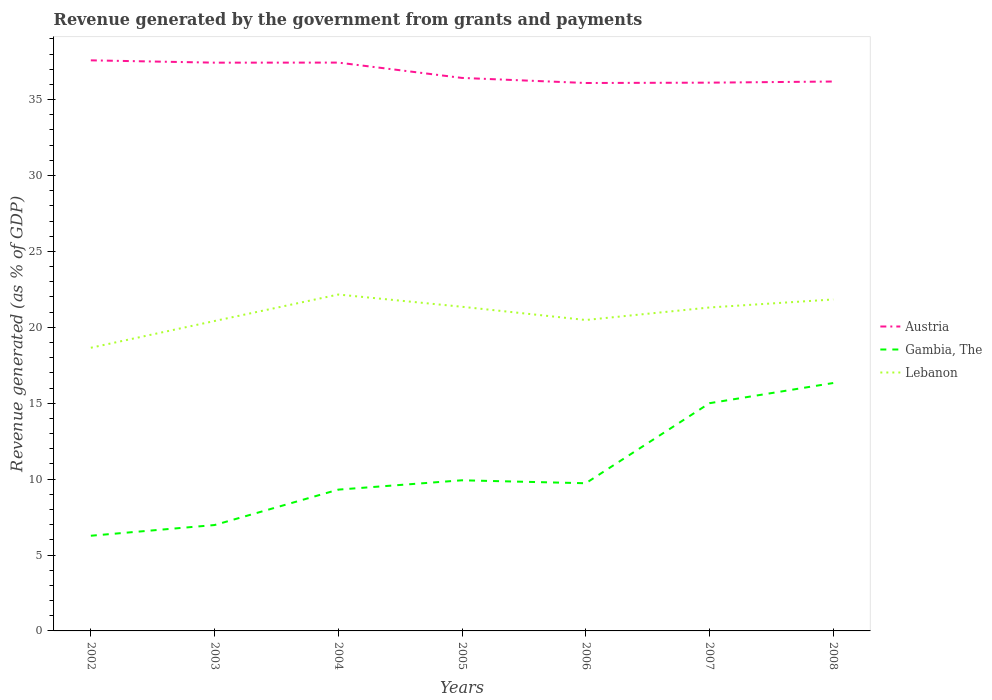How many different coloured lines are there?
Offer a very short reply. 3. Across all years, what is the maximum revenue generated by the government in Austria?
Your answer should be very brief. 36.09. In which year was the revenue generated by the government in Gambia, The maximum?
Keep it short and to the point. 2002. What is the total revenue generated by the government in Gambia, The in the graph?
Keep it short and to the point. -10.06. What is the difference between the highest and the second highest revenue generated by the government in Lebanon?
Offer a very short reply. 3.51. Is the revenue generated by the government in Lebanon strictly greater than the revenue generated by the government in Austria over the years?
Provide a short and direct response. Yes. How many lines are there?
Provide a succinct answer. 3. What is the difference between two consecutive major ticks on the Y-axis?
Give a very brief answer. 5. Does the graph contain any zero values?
Your answer should be very brief. No. Does the graph contain grids?
Give a very brief answer. No. How many legend labels are there?
Provide a succinct answer. 3. How are the legend labels stacked?
Keep it short and to the point. Vertical. What is the title of the graph?
Your response must be concise. Revenue generated by the government from grants and payments. Does "St. Lucia" appear as one of the legend labels in the graph?
Ensure brevity in your answer.  No. What is the label or title of the Y-axis?
Your answer should be very brief. Revenue generated (as % of GDP). What is the Revenue generated (as % of GDP) of Austria in 2002?
Your response must be concise. 37.58. What is the Revenue generated (as % of GDP) of Gambia, The in 2002?
Provide a succinct answer. 6.27. What is the Revenue generated (as % of GDP) in Lebanon in 2002?
Your answer should be compact. 18.65. What is the Revenue generated (as % of GDP) of Austria in 2003?
Your response must be concise. 37.43. What is the Revenue generated (as % of GDP) in Gambia, The in 2003?
Your answer should be very brief. 6.97. What is the Revenue generated (as % of GDP) in Lebanon in 2003?
Keep it short and to the point. 20.41. What is the Revenue generated (as % of GDP) of Austria in 2004?
Offer a very short reply. 37.44. What is the Revenue generated (as % of GDP) of Gambia, The in 2004?
Offer a terse response. 9.31. What is the Revenue generated (as % of GDP) of Lebanon in 2004?
Your answer should be very brief. 22.16. What is the Revenue generated (as % of GDP) in Austria in 2005?
Make the answer very short. 36.43. What is the Revenue generated (as % of GDP) in Gambia, The in 2005?
Make the answer very short. 9.92. What is the Revenue generated (as % of GDP) of Lebanon in 2005?
Offer a very short reply. 21.35. What is the Revenue generated (as % of GDP) of Austria in 2006?
Provide a succinct answer. 36.09. What is the Revenue generated (as % of GDP) of Gambia, The in 2006?
Provide a succinct answer. 9.73. What is the Revenue generated (as % of GDP) in Lebanon in 2006?
Offer a terse response. 20.48. What is the Revenue generated (as % of GDP) of Austria in 2007?
Your response must be concise. 36.11. What is the Revenue generated (as % of GDP) in Gambia, The in 2007?
Offer a very short reply. 15. What is the Revenue generated (as % of GDP) of Lebanon in 2007?
Make the answer very short. 21.31. What is the Revenue generated (as % of GDP) in Austria in 2008?
Make the answer very short. 36.19. What is the Revenue generated (as % of GDP) of Gambia, The in 2008?
Make the answer very short. 16.33. What is the Revenue generated (as % of GDP) in Lebanon in 2008?
Provide a short and direct response. 21.83. Across all years, what is the maximum Revenue generated (as % of GDP) in Austria?
Provide a short and direct response. 37.58. Across all years, what is the maximum Revenue generated (as % of GDP) of Gambia, The?
Keep it short and to the point. 16.33. Across all years, what is the maximum Revenue generated (as % of GDP) of Lebanon?
Your response must be concise. 22.16. Across all years, what is the minimum Revenue generated (as % of GDP) of Austria?
Your response must be concise. 36.09. Across all years, what is the minimum Revenue generated (as % of GDP) in Gambia, The?
Your answer should be compact. 6.27. Across all years, what is the minimum Revenue generated (as % of GDP) of Lebanon?
Make the answer very short. 18.65. What is the total Revenue generated (as % of GDP) of Austria in the graph?
Your answer should be very brief. 257.28. What is the total Revenue generated (as % of GDP) of Gambia, The in the graph?
Ensure brevity in your answer.  73.53. What is the total Revenue generated (as % of GDP) in Lebanon in the graph?
Give a very brief answer. 146.2. What is the difference between the Revenue generated (as % of GDP) of Austria in 2002 and that in 2003?
Ensure brevity in your answer.  0.15. What is the difference between the Revenue generated (as % of GDP) in Gambia, The in 2002 and that in 2003?
Give a very brief answer. -0.71. What is the difference between the Revenue generated (as % of GDP) in Lebanon in 2002 and that in 2003?
Keep it short and to the point. -1.76. What is the difference between the Revenue generated (as % of GDP) in Austria in 2002 and that in 2004?
Your answer should be compact. 0.15. What is the difference between the Revenue generated (as % of GDP) of Gambia, The in 2002 and that in 2004?
Ensure brevity in your answer.  -3.04. What is the difference between the Revenue generated (as % of GDP) in Lebanon in 2002 and that in 2004?
Your answer should be compact. -3.51. What is the difference between the Revenue generated (as % of GDP) of Austria in 2002 and that in 2005?
Your answer should be compact. 1.16. What is the difference between the Revenue generated (as % of GDP) in Gambia, The in 2002 and that in 2005?
Your answer should be compact. -3.65. What is the difference between the Revenue generated (as % of GDP) of Lebanon in 2002 and that in 2005?
Your answer should be compact. -2.7. What is the difference between the Revenue generated (as % of GDP) in Austria in 2002 and that in 2006?
Offer a terse response. 1.49. What is the difference between the Revenue generated (as % of GDP) of Gambia, The in 2002 and that in 2006?
Make the answer very short. -3.46. What is the difference between the Revenue generated (as % of GDP) in Lebanon in 2002 and that in 2006?
Provide a succinct answer. -1.83. What is the difference between the Revenue generated (as % of GDP) of Austria in 2002 and that in 2007?
Your response must be concise. 1.47. What is the difference between the Revenue generated (as % of GDP) of Gambia, The in 2002 and that in 2007?
Provide a succinct answer. -8.73. What is the difference between the Revenue generated (as % of GDP) in Lebanon in 2002 and that in 2007?
Your response must be concise. -2.65. What is the difference between the Revenue generated (as % of GDP) of Austria in 2002 and that in 2008?
Provide a short and direct response. 1.39. What is the difference between the Revenue generated (as % of GDP) of Gambia, The in 2002 and that in 2008?
Your answer should be very brief. -10.06. What is the difference between the Revenue generated (as % of GDP) of Lebanon in 2002 and that in 2008?
Provide a succinct answer. -3.18. What is the difference between the Revenue generated (as % of GDP) in Austria in 2003 and that in 2004?
Your answer should be very brief. -0. What is the difference between the Revenue generated (as % of GDP) in Gambia, The in 2003 and that in 2004?
Your answer should be compact. -2.33. What is the difference between the Revenue generated (as % of GDP) of Lebanon in 2003 and that in 2004?
Offer a very short reply. -1.74. What is the difference between the Revenue generated (as % of GDP) in Austria in 2003 and that in 2005?
Make the answer very short. 1.01. What is the difference between the Revenue generated (as % of GDP) of Gambia, The in 2003 and that in 2005?
Keep it short and to the point. -2.95. What is the difference between the Revenue generated (as % of GDP) of Lebanon in 2003 and that in 2005?
Your response must be concise. -0.94. What is the difference between the Revenue generated (as % of GDP) in Austria in 2003 and that in 2006?
Give a very brief answer. 1.34. What is the difference between the Revenue generated (as % of GDP) in Gambia, The in 2003 and that in 2006?
Offer a very short reply. -2.75. What is the difference between the Revenue generated (as % of GDP) of Lebanon in 2003 and that in 2006?
Provide a short and direct response. -0.07. What is the difference between the Revenue generated (as % of GDP) in Austria in 2003 and that in 2007?
Keep it short and to the point. 1.32. What is the difference between the Revenue generated (as % of GDP) in Gambia, The in 2003 and that in 2007?
Offer a terse response. -8.03. What is the difference between the Revenue generated (as % of GDP) of Lebanon in 2003 and that in 2007?
Make the answer very short. -0.89. What is the difference between the Revenue generated (as % of GDP) of Austria in 2003 and that in 2008?
Provide a short and direct response. 1.24. What is the difference between the Revenue generated (as % of GDP) of Gambia, The in 2003 and that in 2008?
Ensure brevity in your answer.  -9.36. What is the difference between the Revenue generated (as % of GDP) of Lebanon in 2003 and that in 2008?
Give a very brief answer. -1.42. What is the difference between the Revenue generated (as % of GDP) of Austria in 2004 and that in 2005?
Give a very brief answer. 1.01. What is the difference between the Revenue generated (as % of GDP) in Gambia, The in 2004 and that in 2005?
Offer a terse response. -0.62. What is the difference between the Revenue generated (as % of GDP) of Lebanon in 2004 and that in 2005?
Your answer should be very brief. 0.81. What is the difference between the Revenue generated (as % of GDP) in Austria in 2004 and that in 2006?
Your answer should be very brief. 1.34. What is the difference between the Revenue generated (as % of GDP) in Gambia, The in 2004 and that in 2006?
Provide a short and direct response. -0.42. What is the difference between the Revenue generated (as % of GDP) in Lebanon in 2004 and that in 2006?
Give a very brief answer. 1.68. What is the difference between the Revenue generated (as % of GDP) of Austria in 2004 and that in 2007?
Your response must be concise. 1.32. What is the difference between the Revenue generated (as % of GDP) in Gambia, The in 2004 and that in 2007?
Give a very brief answer. -5.69. What is the difference between the Revenue generated (as % of GDP) of Lebanon in 2004 and that in 2007?
Offer a terse response. 0.85. What is the difference between the Revenue generated (as % of GDP) of Austria in 2004 and that in 2008?
Your response must be concise. 1.25. What is the difference between the Revenue generated (as % of GDP) of Gambia, The in 2004 and that in 2008?
Your answer should be compact. -7.02. What is the difference between the Revenue generated (as % of GDP) of Lebanon in 2004 and that in 2008?
Provide a short and direct response. 0.33. What is the difference between the Revenue generated (as % of GDP) in Austria in 2005 and that in 2006?
Ensure brevity in your answer.  0.33. What is the difference between the Revenue generated (as % of GDP) in Gambia, The in 2005 and that in 2006?
Your response must be concise. 0.2. What is the difference between the Revenue generated (as % of GDP) of Lebanon in 2005 and that in 2006?
Provide a short and direct response. 0.87. What is the difference between the Revenue generated (as % of GDP) of Austria in 2005 and that in 2007?
Ensure brevity in your answer.  0.31. What is the difference between the Revenue generated (as % of GDP) in Gambia, The in 2005 and that in 2007?
Provide a succinct answer. -5.08. What is the difference between the Revenue generated (as % of GDP) of Lebanon in 2005 and that in 2007?
Ensure brevity in your answer.  0.05. What is the difference between the Revenue generated (as % of GDP) in Austria in 2005 and that in 2008?
Ensure brevity in your answer.  0.24. What is the difference between the Revenue generated (as % of GDP) in Gambia, The in 2005 and that in 2008?
Provide a succinct answer. -6.41. What is the difference between the Revenue generated (as % of GDP) in Lebanon in 2005 and that in 2008?
Provide a succinct answer. -0.48. What is the difference between the Revenue generated (as % of GDP) of Austria in 2006 and that in 2007?
Provide a short and direct response. -0.02. What is the difference between the Revenue generated (as % of GDP) in Gambia, The in 2006 and that in 2007?
Your response must be concise. -5.27. What is the difference between the Revenue generated (as % of GDP) in Lebanon in 2006 and that in 2007?
Provide a succinct answer. -0.82. What is the difference between the Revenue generated (as % of GDP) of Austria in 2006 and that in 2008?
Your answer should be very brief. -0.1. What is the difference between the Revenue generated (as % of GDP) of Gambia, The in 2006 and that in 2008?
Offer a very short reply. -6.6. What is the difference between the Revenue generated (as % of GDP) of Lebanon in 2006 and that in 2008?
Keep it short and to the point. -1.35. What is the difference between the Revenue generated (as % of GDP) in Austria in 2007 and that in 2008?
Provide a short and direct response. -0.07. What is the difference between the Revenue generated (as % of GDP) of Gambia, The in 2007 and that in 2008?
Your answer should be compact. -1.33. What is the difference between the Revenue generated (as % of GDP) in Lebanon in 2007 and that in 2008?
Ensure brevity in your answer.  -0.53. What is the difference between the Revenue generated (as % of GDP) of Austria in 2002 and the Revenue generated (as % of GDP) of Gambia, The in 2003?
Make the answer very short. 30.61. What is the difference between the Revenue generated (as % of GDP) in Austria in 2002 and the Revenue generated (as % of GDP) in Lebanon in 2003?
Your response must be concise. 17.17. What is the difference between the Revenue generated (as % of GDP) of Gambia, The in 2002 and the Revenue generated (as % of GDP) of Lebanon in 2003?
Make the answer very short. -14.15. What is the difference between the Revenue generated (as % of GDP) in Austria in 2002 and the Revenue generated (as % of GDP) in Gambia, The in 2004?
Offer a terse response. 28.28. What is the difference between the Revenue generated (as % of GDP) of Austria in 2002 and the Revenue generated (as % of GDP) of Lebanon in 2004?
Provide a succinct answer. 15.43. What is the difference between the Revenue generated (as % of GDP) of Gambia, The in 2002 and the Revenue generated (as % of GDP) of Lebanon in 2004?
Offer a terse response. -15.89. What is the difference between the Revenue generated (as % of GDP) in Austria in 2002 and the Revenue generated (as % of GDP) in Gambia, The in 2005?
Your response must be concise. 27.66. What is the difference between the Revenue generated (as % of GDP) of Austria in 2002 and the Revenue generated (as % of GDP) of Lebanon in 2005?
Provide a succinct answer. 16.23. What is the difference between the Revenue generated (as % of GDP) in Gambia, The in 2002 and the Revenue generated (as % of GDP) in Lebanon in 2005?
Offer a terse response. -15.08. What is the difference between the Revenue generated (as % of GDP) of Austria in 2002 and the Revenue generated (as % of GDP) of Gambia, The in 2006?
Provide a short and direct response. 27.86. What is the difference between the Revenue generated (as % of GDP) of Austria in 2002 and the Revenue generated (as % of GDP) of Lebanon in 2006?
Offer a very short reply. 17.1. What is the difference between the Revenue generated (as % of GDP) of Gambia, The in 2002 and the Revenue generated (as % of GDP) of Lebanon in 2006?
Your response must be concise. -14.21. What is the difference between the Revenue generated (as % of GDP) in Austria in 2002 and the Revenue generated (as % of GDP) in Gambia, The in 2007?
Your answer should be very brief. 22.58. What is the difference between the Revenue generated (as % of GDP) in Austria in 2002 and the Revenue generated (as % of GDP) in Lebanon in 2007?
Your answer should be very brief. 16.28. What is the difference between the Revenue generated (as % of GDP) of Gambia, The in 2002 and the Revenue generated (as % of GDP) of Lebanon in 2007?
Your response must be concise. -15.04. What is the difference between the Revenue generated (as % of GDP) in Austria in 2002 and the Revenue generated (as % of GDP) in Gambia, The in 2008?
Make the answer very short. 21.25. What is the difference between the Revenue generated (as % of GDP) in Austria in 2002 and the Revenue generated (as % of GDP) in Lebanon in 2008?
Offer a terse response. 15.75. What is the difference between the Revenue generated (as % of GDP) of Gambia, The in 2002 and the Revenue generated (as % of GDP) of Lebanon in 2008?
Make the answer very short. -15.56. What is the difference between the Revenue generated (as % of GDP) in Austria in 2003 and the Revenue generated (as % of GDP) in Gambia, The in 2004?
Your response must be concise. 28.12. What is the difference between the Revenue generated (as % of GDP) of Austria in 2003 and the Revenue generated (as % of GDP) of Lebanon in 2004?
Provide a succinct answer. 15.27. What is the difference between the Revenue generated (as % of GDP) in Gambia, The in 2003 and the Revenue generated (as % of GDP) in Lebanon in 2004?
Provide a succinct answer. -15.18. What is the difference between the Revenue generated (as % of GDP) of Austria in 2003 and the Revenue generated (as % of GDP) of Gambia, The in 2005?
Provide a succinct answer. 27.51. What is the difference between the Revenue generated (as % of GDP) in Austria in 2003 and the Revenue generated (as % of GDP) in Lebanon in 2005?
Your answer should be compact. 16.08. What is the difference between the Revenue generated (as % of GDP) of Gambia, The in 2003 and the Revenue generated (as % of GDP) of Lebanon in 2005?
Provide a succinct answer. -14.38. What is the difference between the Revenue generated (as % of GDP) in Austria in 2003 and the Revenue generated (as % of GDP) in Gambia, The in 2006?
Keep it short and to the point. 27.7. What is the difference between the Revenue generated (as % of GDP) of Austria in 2003 and the Revenue generated (as % of GDP) of Lebanon in 2006?
Make the answer very short. 16.95. What is the difference between the Revenue generated (as % of GDP) in Gambia, The in 2003 and the Revenue generated (as % of GDP) in Lebanon in 2006?
Keep it short and to the point. -13.51. What is the difference between the Revenue generated (as % of GDP) in Austria in 2003 and the Revenue generated (as % of GDP) in Gambia, The in 2007?
Ensure brevity in your answer.  22.43. What is the difference between the Revenue generated (as % of GDP) of Austria in 2003 and the Revenue generated (as % of GDP) of Lebanon in 2007?
Offer a terse response. 16.13. What is the difference between the Revenue generated (as % of GDP) of Gambia, The in 2003 and the Revenue generated (as % of GDP) of Lebanon in 2007?
Keep it short and to the point. -14.33. What is the difference between the Revenue generated (as % of GDP) in Austria in 2003 and the Revenue generated (as % of GDP) in Gambia, The in 2008?
Your response must be concise. 21.1. What is the difference between the Revenue generated (as % of GDP) of Austria in 2003 and the Revenue generated (as % of GDP) of Lebanon in 2008?
Make the answer very short. 15.6. What is the difference between the Revenue generated (as % of GDP) in Gambia, The in 2003 and the Revenue generated (as % of GDP) in Lebanon in 2008?
Keep it short and to the point. -14.86. What is the difference between the Revenue generated (as % of GDP) of Austria in 2004 and the Revenue generated (as % of GDP) of Gambia, The in 2005?
Your answer should be compact. 27.51. What is the difference between the Revenue generated (as % of GDP) in Austria in 2004 and the Revenue generated (as % of GDP) in Lebanon in 2005?
Provide a short and direct response. 16.08. What is the difference between the Revenue generated (as % of GDP) in Gambia, The in 2004 and the Revenue generated (as % of GDP) in Lebanon in 2005?
Offer a very short reply. -12.05. What is the difference between the Revenue generated (as % of GDP) of Austria in 2004 and the Revenue generated (as % of GDP) of Gambia, The in 2006?
Your answer should be compact. 27.71. What is the difference between the Revenue generated (as % of GDP) in Austria in 2004 and the Revenue generated (as % of GDP) in Lebanon in 2006?
Your answer should be compact. 16.96. What is the difference between the Revenue generated (as % of GDP) in Gambia, The in 2004 and the Revenue generated (as % of GDP) in Lebanon in 2006?
Make the answer very short. -11.17. What is the difference between the Revenue generated (as % of GDP) of Austria in 2004 and the Revenue generated (as % of GDP) of Gambia, The in 2007?
Offer a very short reply. 22.44. What is the difference between the Revenue generated (as % of GDP) of Austria in 2004 and the Revenue generated (as % of GDP) of Lebanon in 2007?
Give a very brief answer. 16.13. What is the difference between the Revenue generated (as % of GDP) in Gambia, The in 2004 and the Revenue generated (as % of GDP) in Lebanon in 2007?
Keep it short and to the point. -12. What is the difference between the Revenue generated (as % of GDP) of Austria in 2004 and the Revenue generated (as % of GDP) of Gambia, The in 2008?
Offer a terse response. 21.11. What is the difference between the Revenue generated (as % of GDP) in Austria in 2004 and the Revenue generated (as % of GDP) in Lebanon in 2008?
Your answer should be very brief. 15.6. What is the difference between the Revenue generated (as % of GDP) of Gambia, The in 2004 and the Revenue generated (as % of GDP) of Lebanon in 2008?
Provide a short and direct response. -12.53. What is the difference between the Revenue generated (as % of GDP) in Austria in 2005 and the Revenue generated (as % of GDP) in Gambia, The in 2006?
Offer a very short reply. 26.7. What is the difference between the Revenue generated (as % of GDP) of Austria in 2005 and the Revenue generated (as % of GDP) of Lebanon in 2006?
Provide a succinct answer. 15.95. What is the difference between the Revenue generated (as % of GDP) of Gambia, The in 2005 and the Revenue generated (as % of GDP) of Lebanon in 2006?
Your answer should be very brief. -10.56. What is the difference between the Revenue generated (as % of GDP) of Austria in 2005 and the Revenue generated (as % of GDP) of Gambia, The in 2007?
Ensure brevity in your answer.  21.43. What is the difference between the Revenue generated (as % of GDP) of Austria in 2005 and the Revenue generated (as % of GDP) of Lebanon in 2007?
Offer a very short reply. 15.12. What is the difference between the Revenue generated (as % of GDP) in Gambia, The in 2005 and the Revenue generated (as % of GDP) in Lebanon in 2007?
Offer a very short reply. -11.38. What is the difference between the Revenue generated (as % of GDP) in Austria in 2005 and the Revenue generated (as % of GDP) in Gambia, The in 2008?
Provide a short and direct response. 20.1. What is the difference between the Revenue generated (as % of GDP) of Austria in 2005 and the Revenue generated (as % of GDP) of Lebanon in 2008?
Ensure brevity in your answer.  14.59. What is the difference between the Revenue generated (as % of GDP) in Gambia, The in 2005 and the Revenue generated (as % of GDP) in Lebanon in 2008?
Offer a very short reply. -11.91. What is the difference between the Revenue generated (as % of GDP) in Austria in 2006 and the Revenue generated (as % of GDP) in Gambia, The in 2007?
Your answer should be compact. 21.09. What is the difference between the Revenue generated (as % of GDP) in Austria in 2006 and the Revenue generated (as % of GDP) in Lebanon in 2007?
Keep it short and to the point. 14.79. What is the difference between the Revenue generated (as % of GDP) of Gambia, The in 2006 and the Revenue generated (as % of GDP) of Lebanon in 2007?
Offer a terse response. -11.58. What is the difference between the Revenue generated (as % of GDP) of Austria in 2006 and the Revenue generated (as % of GDP) of Gambia, The in 2008?
Your answer should be very brief. 19.76. What is the difference between the Revenue generated (as % of GDP) of Austria in 2006 and the Revenue generated (as % of GDP) of Lebanon in 2008?
Offer a terse response. 14.26. What is the difference between the Revenue generated (as % of GDP) of Gambia, The in 2006 and the Revenue generated (as % of GDP) of Lebanon in 2008?
Ensure brevity in your answer.  -12.11. What is the difference between the Revenue generated (as % of GDP) in Austria in 2007 and the Revenue generated (as % of GDP) in Gambia, The in 2008?
Give a very brief answer. 19.78. What is the difference between the Revenue generated (as % of GDP) of Austria in 2007 and the Revenue generated (as % of GDP) of Lebanon in 2008?
Provide a short and direct response. 14.28. What is the difference between the Revenue generated (as % of GDP) in Gambia, The in 2007 and the Revenue generated (as % of GDP) in Lebanon in 2008?
Offer a terse response. -6.83. What is the average Revenue generated (as % of GDP) in Austria per year?
Offer a very short reply. 36.75. What is the average Revenue generated (as % of GDP) in Gambia, The per year?
Offer a terse response. 10.5. What is the average Revenue generated (as % of GDP) of Lebanon per year?
Ensure brevity in your answer.  20.89. In the year 2002, what is the difference between the Revenue generated (as % of GDP) of Austria and Revenue generated (as % of GDP) of Gambia, The?
Provide a short and direct response. 31.31. In the year 2002, what is the difference between the Revenue generated (as % of GDP) of Austria and Revenue generated (as % of GDP) of Lebanon?
Your response must be concise. 18.93. In the year 2002, what is the difference between the Revenue generated (as % of GDP) in Gambia, The and Revenue generated (as % of GDP) in Lebanon?
Offer a very short reply. -12.38. In the year 2003, what is the difference between the Revenue generated (as % of GDP) of Austria and Revenue generated (as % of GDP) of Gambia, The?
Your answer should be very brief. 30.46. In the year 2003, what is the difference between the Revenue generated (as % of GDP) of Austria and Revenue generated (as % of GDP) of Lebanon?
Your answer should be compact. 17.02. In the year 2003, what is the difference between the Revenue generated (as % of GDP) in Gambia, The and Revenue generated (as % of GDP) in Lebanon?
Keep it short and to the point. -13.44. In the year 2004, what is the difference between the Revenue generated (as % of GDP) in Austria and Revenue generated (as % of GDP) in Gambia, The?
Your answer should be compact. 28.13. In the year 2004, what is the difference between the Revenue generated (as % of GDP) of Austria and Revenue generated (as % of GDP) of Lebanon?
Offer a very short reply. 15.28. In the year 2004, what is the difference between the Revenue generated (as % of GDP) in Gambia, The and Revenue generated (as % of GDP) in Lebanon?
Keep it short and to the point. -12.85. In the year 2005, what is the difference between the Revenue generated (as % of GDP) in Austria and Revenue generated (as % of GDP) in Gambia, The?
Your response must be concise. 26.5. In the year 2005, what is the difference between the Revenue generated (as % of GDP) of Austria and Revenue generated (as % of GDP) of Lebanon?
Make the answer very short. 15.07. In the year 2005, what is the difference between the Revenue generated (as % of GDP) in Gambia, The and Revenue generated (as % of GDP) in Lebanon?
Make the answer very short. -11.43. In the year 2006, what is the difference between the Revenue generated (as % of GDP) in Austria and Revenue generated (as % of GDP) in Gambia, The?
Give a very brief answer. 26.37. In the year 2006, what is the difference between the Revenue generated (as % of GDP) in Austria and Revenue generated (as % of GDP) in Lebanon?
Your answer should be compact. 15.61. In the year 2006, what is the difference between the Revenue generated (as % of GDP) of Gambia, The and Revenue generated (as % of GDP) of Lebanon?
Provide a succinct answer. -10.75. In the year 2007, what is the difference between the Revenue generated (as % of GDP) of Austria and Revenue generated (as % of GDP) of Gambia, The?
Your answer should be compact. 21.11. In the year 2007, what is the difference between the Revenue generated (as % of GDP) in Austria and Revenue generated (as % of GDP) in Lebanon?
Make the answer very short. 14.81. In the year 2007, what is the difference between the Revenue generated (as % of GDP) of Gambia, The and Revenue generated (as % of GDP) of Lebanon?
Keep it short and to the point. -6.31. In the year 2008, what is the difference between the Revenue generated (as % of GDP) of Austria and Revenue generated (as % of GDP) of Gambia, The?
Your answer should be compact. 19.86. In the year 2008, what is the difference between the Revenue generated (as % of GDP) in Austria and Revenue generated (as % of GDP) in Lebanon?
Offer a terse response. 14.36. In the year 2008, what is the difference between the Revenue generated (as % of GDP) in Gambia, The and Revenue generated (as % of GDP) in Lebanon?
Provide a short and direct response. -5.5. What is the ratio of the Revenue generated (as % of GDP) of Gambia, The in 2002 to that in 2003?
Offer a terse response. 0.9. What is the ratio of the Revenue generated (as % of GDP) in Lebanon in 2002 to that in 2003?
Your response must be concise. 0.91. What is the ratio of the Revenue generated (as % of GDP) of Gambia, The in 2002 to that in 2004?
Provide a short and direct response. 0.67. What is the ratio of the Revenue generated (as % of GDP) of Lebanon in 2002 to that in 2004?
Your response must be concise. 0.84. What is the ratio of the Revenue generated (as % of GDP) in Austria in 2002 to that in 2005?
Offer a very short reply. 1.03. What is the ratio of the Revenue generated (as % of GDP) of Gambia, The in 2002 to that in 2005?
Your answer should be very brief. 0.63. What is the ratio of the Revenue generated (as % of GDP) in Lebanon in 2002 to that in 2005?
Your answer should be compact. 0.87. What is the ratio of the Revenue generated (as % of GDP) of Austria in 2002 to that in 2006?
Offer a terse response. 1.04. What is the ratio of the Revenue generated (as % of GDP) in Gambia, The in 2002 to that in 2006?
Give a very brief answer. 0.64. What is the ratio of the Revenue generated (as % of GDP) in Lebanon in 2002 to that in 2006?
Provide a short and direct response. 0.91. What is the ratio of the Revenue generated (as % of GDP) of Austria in 2002 to that in 2007?
Provide a succinct answer. 1.04. What is the ratio of the Revenue generated (as % of GDP) of Gambia, The in 2002 to that in 2007?
Offer a terse response. 0.42. What is the ratio of the Revenue generated (as % of GDP) of Lebanon in 2002 to that in 2007?
Offer a terse response. 0.88. What is the ratio of the Revenue generated (as % of GDP) in Austria in 2002 to that in 2008?
Offer a terse response. 1.04. What is the ratio of the Revenue generated (as % of GDP) in Gambia, The in 2002 to that in 2008?
Provide a succinct answer. 0.38. What is the ratio of the Revenue generated (as % of GDP) of Lebanon in 2002 to that in 2008?
Give a very brief answer. 0.85. What is the ratio of the Revenue generated (as % of GDP) in Austria in 2003 to that in 2004?
Make the answer very short. 1. What is the ratio of the Revenue generated (as % of GDP) in Gambia, The in 2003 to that in 2004?
Give a very brief answer. 0.75. What is the ratio of the Revenue generated (as % of GDP) of Lebanon in 2003 to that in 2004?
Give a very brief answer. 0.92. What is the ratio of the Revenue generated (as % of GDP) of Austria in 2003 to that in 2005?
Your response must be concise. 1.03. What is the ratio of the Revenue generated (as % of GDP) in Gambia, The in 2003 to that in 2005?
Give a very brief answer. 0.7. What is the ratio of the Revenue generated (as % of GDP) in Lebanon in 2003 to that in 2005?
Offer a very short reply. 0.96. What is the ratio of the Revenue generated (as % of GDP) of Austria in 2003 to that in 2006?
Keep it short and to the point. 1.04. What is the ratio of the Revenue generated (as % of GDP) of Gambia, The in 2003 to that in 2006?
Offer a terse response. 0.72. What is the ratio of the Revenue generated (as % of GDP) of Lebanon in 2003 to that in 2006?
Keep it short and to the point. 1. What is the ratio of the Revenue generated (as % of GDP) in Austria in 2003 to that in 2007?
Provide a short and direct response. 1.04. What is the ratio of the Revenue generated (as % of GDP) in Gambia, The in 2003 to that in 2007?
Make the answer very short. 0.47. What is the ratio of the Revenue generated (as % of GDP) of Lebanon in 2003 to that in 2007?
Offer a very short reply. 0.96. What is the ratio of the Revenue generated (as % of GDP) of Austria in 2003 to that in 2008?
Offer a very short reply. 1.03. What is the ratio of the Revenue generated (as % of GDP) in Gambia, The in 2003 to that in 2008?
Your answer should be very brief. 0.43. What is the ratio of the Revenue generated (as % of GDP) of Lebanon in 2003 to that in 2008?
Give a very brief answer. 0.94. What is the ratio of the Revenue generated (as % of GDP) in Austria in 2004 to that in 2005?
Provide a short and direct response. 1.03. What is the ratio of the Revenue generated (as % of GDP) in Gambia, The in 2004 to that in 2005?
Offer a terse response. 0.94. What is the ratio of the Revenue generated (as % of GDP) in Lebanon in 2004 to that in 2005?
Provide a succinct answer. 1.04. What is the ratio of the Revenue generated (as % of GDP) in Austria in 2004 to that in 2006?
Give a very brief answer. 1.04. What is the ratio of the Revenue generated (as % of GDP) of Gambia, The in 2004 to that in 2006?
Offer a very short reply. 0.96. What is the ratio of the Revenue generated (as % of GDP) in Lebanon in 2004 to that in 2006?
Provide a succinct answer. 1.08. What is the ratio of the Revenue generated (as % of GDP) in Austria in 2004 to that in 2007?
Provide a succinct answer. 1.04. What is the ratio of the Revenue generated (as % of GDP) in Gambia, The in 2004 to that in 2007?
Offer a very short reply. 0.62. What is the ratio of the Revenue generated (as % of GDP) in Lebanon in 2004 to that in 2007?
Offer a very short reply. 1.04. What is the ratio of the Revenue generated (as % of GDP) of Austria in 2004 to that in 2008?
Give a very brief answer. 1.03. What is the ratio of the Revenue generated (as % of GDP) of Gambia, The in 2004 to that in 2008?
Offer a very short reply. 0.57. What is the ratio of the Revenue generated (as % of GDP) in Lebanon in 2004 to that in 2008?
Your response must be concise. 1.01. What is the ratio of the Revenue generated (as % of GDP) of Austria in 2005 to that in 2006?
Provide a short and direct response. 1.01. What is the ratio of the Revenue generated (as % of GDP) of Gambia, The in 2005 to that in 2006?
Your response must be concise. 1.02. What is the ratio of the Revenue generated (as % of GDP) in Lebanon in 2005 to that in 2006?
Ensure brevity in your answer.  1.04. What is the ratio of the Revenue generated (as % of GDP) of Austria in 2005 to that in 2007?
Your answer should be very brief. 1.01. What is the ratio of the Revenue generated (as % of GDP) of Gambia, The in 2005 to that in 2007?
Your response must be concise. 0.66. What is the ratio of the Revenue generated (as % of GDP) in Gambia, The in 2005 to that in 2008?
Offer a very short reply. 0.61. What is the ratio of the Revenue generated (as % of GDP) in Lebanon in 2005 to that in 2008?
Offer a very short reply. 0.98. What is the ratio of the Revenue generated (as % of GDP) of Gambia, The in 2006 to that in 2007?
Ensure brevity in your answer.  0.65. What is the ratio of the Revenue generated (as % of GDP) of Lebanon in 2006 to that in 2007?
Provide a succinct answer. 0.96. What is the ratio of the Revenue generated (as % of GDP) in Austria in 2006 to that in 2008?
Make the answer very short. 1. What is the ratio of the Revenue generated (as % of GDP) in Gambia, The in 2006 to that in 2008?
Ensure brevity in your answer.  0.6. What is the ratio of the Revenue generated (as % of GDP) in Lebanon in 2006 to that in 2008?
Ensure brevity in your answer.  0.94. What is the ratio of the Revenue generated (as % of GDP) of Austria in 2007 to that in 2008?
Your response must be concise. 1. What is the ratio of the Revenue generated (as % of GDP) in Gambia, The in 2007 to that in 2008?
Ensure brevity in your answer.  0.92. What is the ratio of the Revenue generated (as % of GDP) in Lebanon in 2007 to that in 2008?
Provide a succinct answer. 0.98. What is the difference between the highest and the second highest Revenue generated (as % of GDP) of Austria?
Your response must be concise. 0.15. What is the difference between the highest and the second highest Revenue generated (as % of GDP) of Gambia, The?
Make the answer very short. 1.33. What is the difference between the highest and the second highest Revenue generated (as % of GDP) in Lebanon?
Your response must be concise. 0.33. What is the difference between the highest and the lowest Revenue generated (as % of GDP) of Austria?
Offer a very short reply. 1.49. What is the difference between the highest and the lowest Revenue generated (as % of GDP) in Gambia, The?
Your answer should be very brief. 10.06. What is the difference between the highest and the lowest Revenue generated (as % of GDP) of Lebanon?
Give a very brief answer. 3.51. 